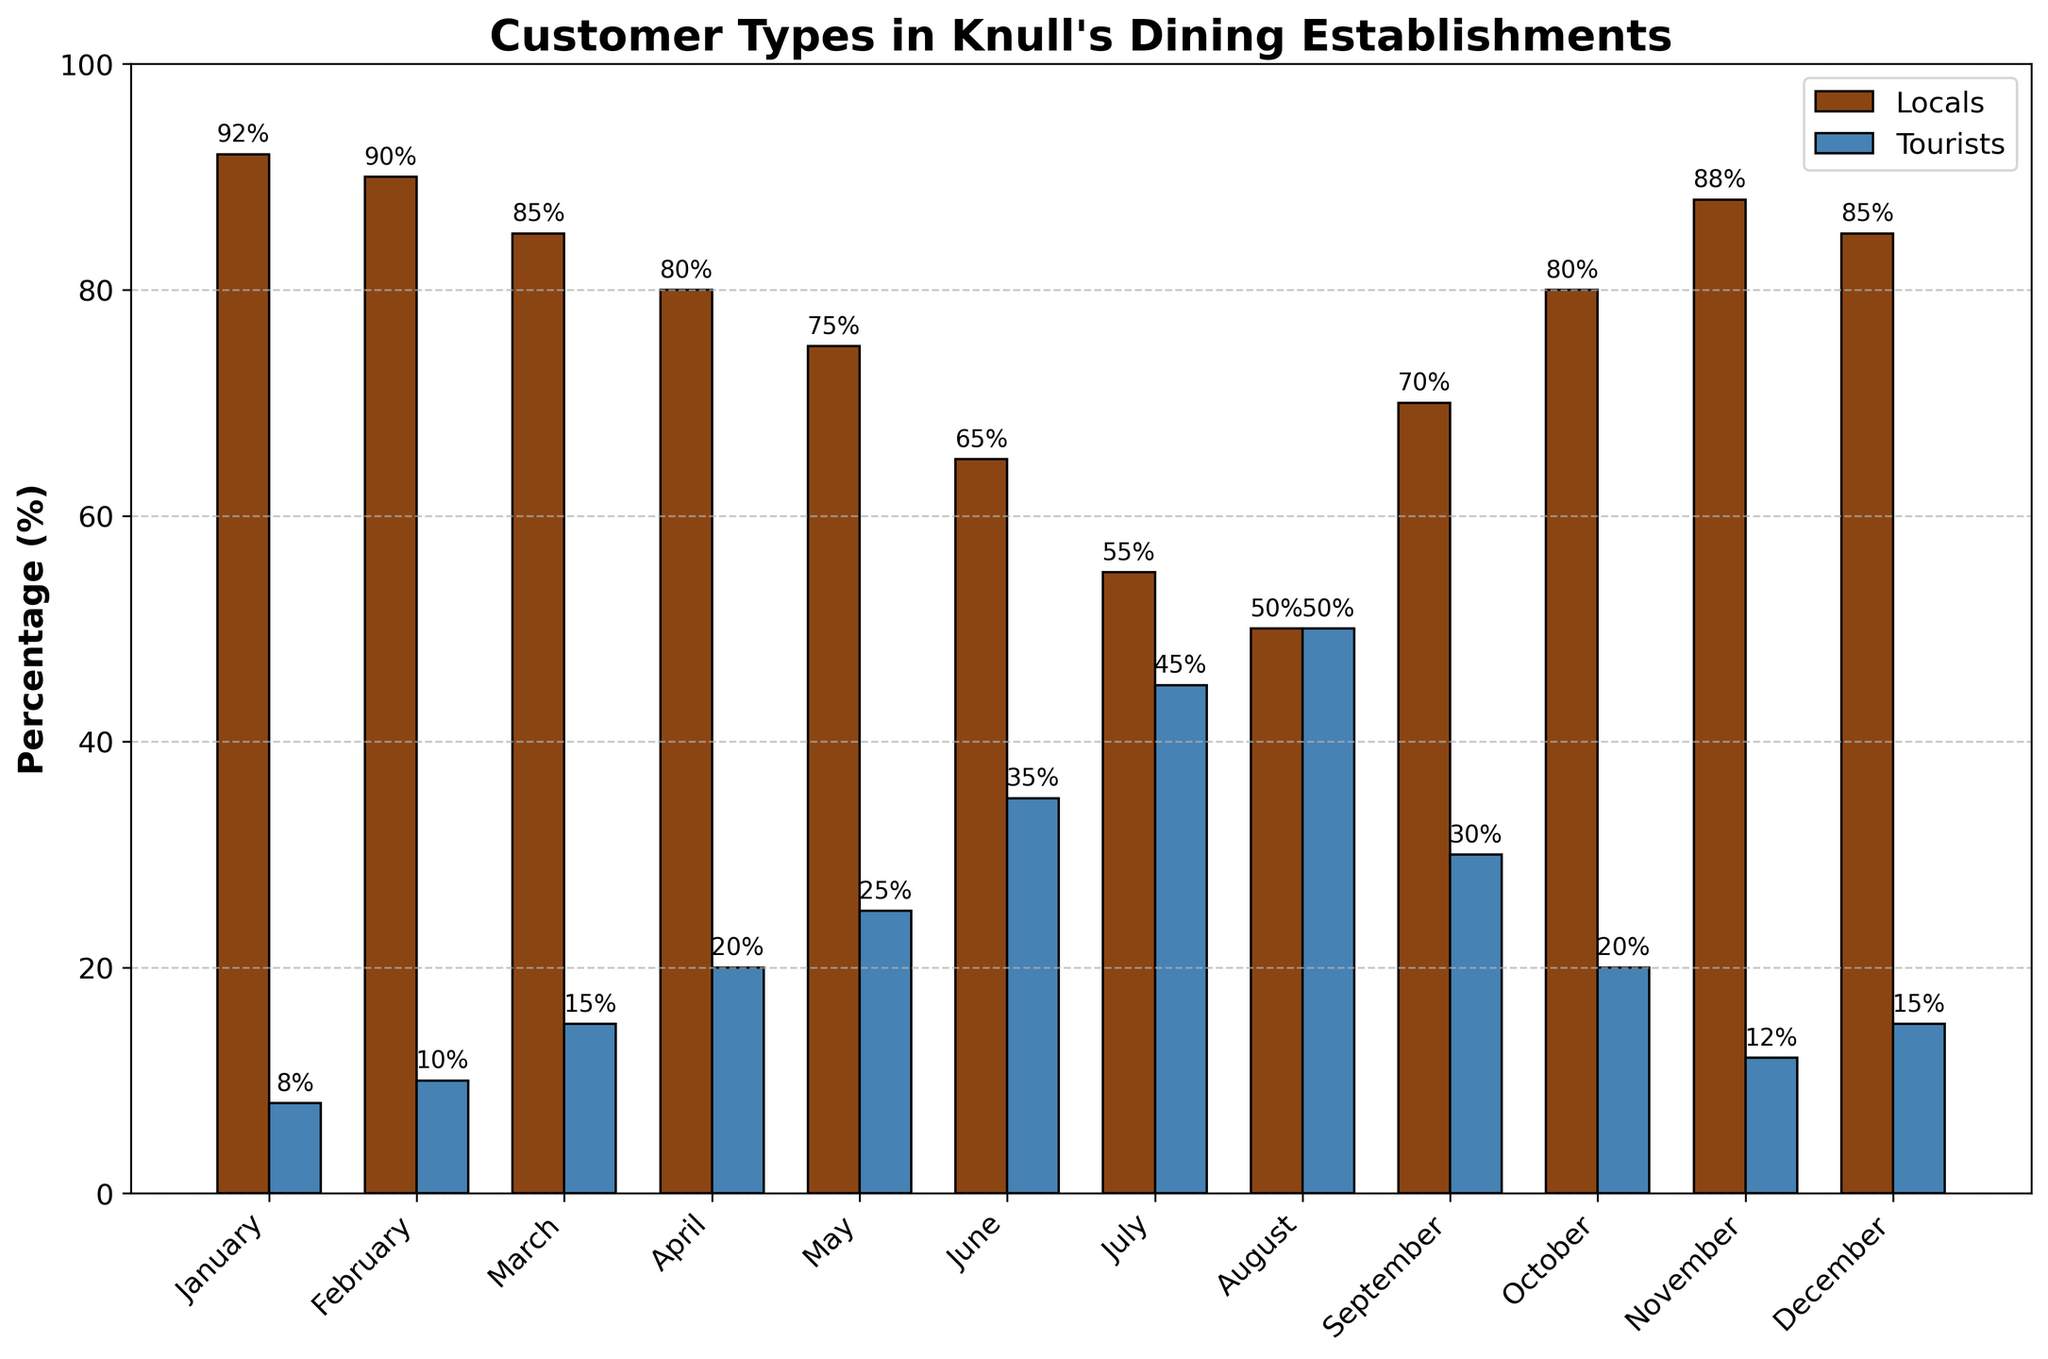What's the percentage difference between locals and tourists in July? In July, 55% of the patrons are locals and 45% are tourists. The percentage difference is calculated as 55% - 45% = 10%.
Answer: 10% Which month has an equal percentage of locals and tourists? From the bar chart, August shows that both locals and tourists each account for 50% of the patrons.
Answer: August During which month do locals constitute the largest percentage of customers? The bar chart shows that in January, locals constitute 92% of the patrons, the highest percentage across all months.
Answer: January How many months have the percentage of tourists greater than 30%? By observing the bar chart, the months where tourists’ percentage is greater than 30% are: June (35%), July (45%), and August (50%). These are three months.
Answer: 3 What is the average percentage of tourists for the months March, April, and May? To calculate the average percentage of tourists for March (15%), April (20%), and May (25%): (15 + 20 + 25) / 3 = 60 / 3 = 20%.
Answer: 20% Is there a trend in the percentage of tourists from January to August? Observing the bar chart, we see a gradual increase in the percentage of tourists from January (8%) to August (50%). This indicates a positive trend.
Answer: Yes What is the combined percentage of locals and tourists in November? In November, locals are 88% and tourists are 12%. Adding them gives 88% + 12% = 100%.
Answer: 100% Compare the customer type percentages between December and March. How much higher is the percentage of tourists in March compared to December? In December, 15% of customers are tourists, and in March, 15% are tourists as well. So, the percentage of tourists in March compared to December is the same: 15% - 15% = 0%.
Answer: 0% Which month shows the greatest decrease in the percentage of locals from the previous month? Comparing the differences between consecutive months, the greatest decrease is from July (55%) to August (50%), a decrease of 5%.
Answer: August 